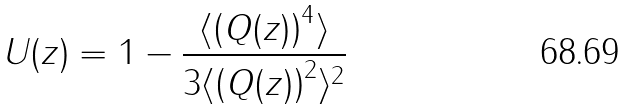<formula> <loc_0><loc_0><loc_500><loc_500>U ( z ) = 1 - \frac { \langle \left ( Q ( z ) \right ) ^ { 4 } \rangle } { 3 \langle \left ( Q ( z ) \right ) ^ { 2 } \rangle ^ { 2 } }</formula> 